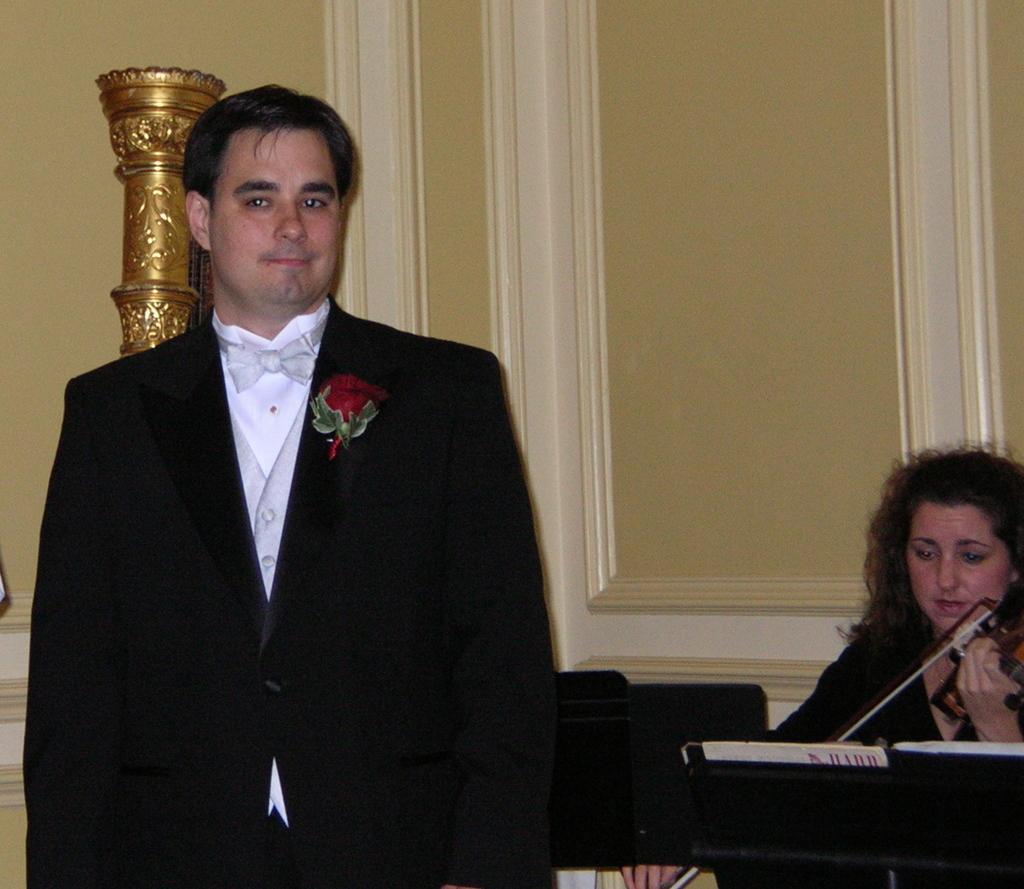How would you summarize this image in a sentence or two? In the picture we can see a man wearing black color suit standing and in the background of the picture there is a woman wearing black color dress playing musical instrument and there is a wall. 